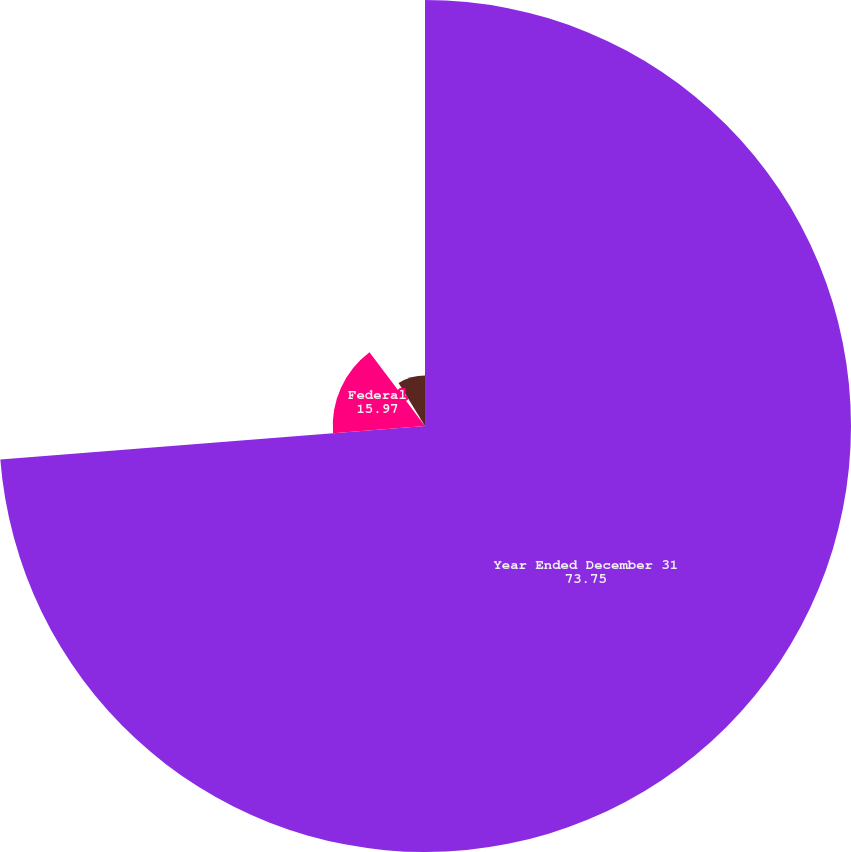Convert chart to OTSL. <chart><loc_0><loc_0><loc_500><loc_500><pie_chart><fcel>Year Ended December 31<fcel>Federal<fcel>State<fcel>Foreign<nl><fcel>73.75%<fcel>15.97%<fcel>1.53%<fcel>8.75%<nl></chart> 